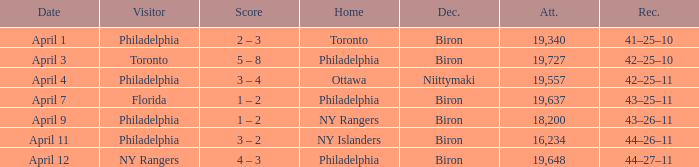Who were the visitors when the home team were the ny rangers? Philadelphia. 